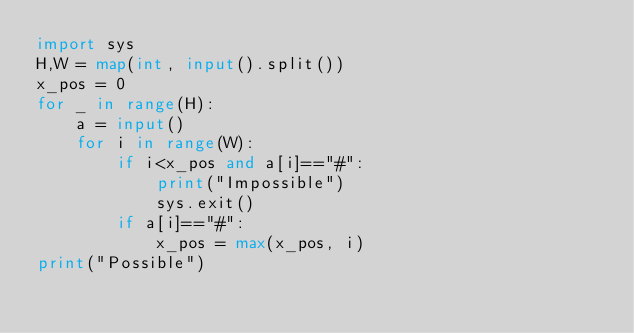<code> <loc_0><loc_0><loc_500><loc_500><_Python_>import sys
H,W = map(int, input().split())
x_pos = 0
for _ in range(H):
    a = input()
    for i in range(W):
        if i<x_pos and a[i]=="#":
            print("Impossible")
            sys.exit()
        if a[i]=="#":
            x_pos = max(x_pos, i)
print("Possible")</code> 